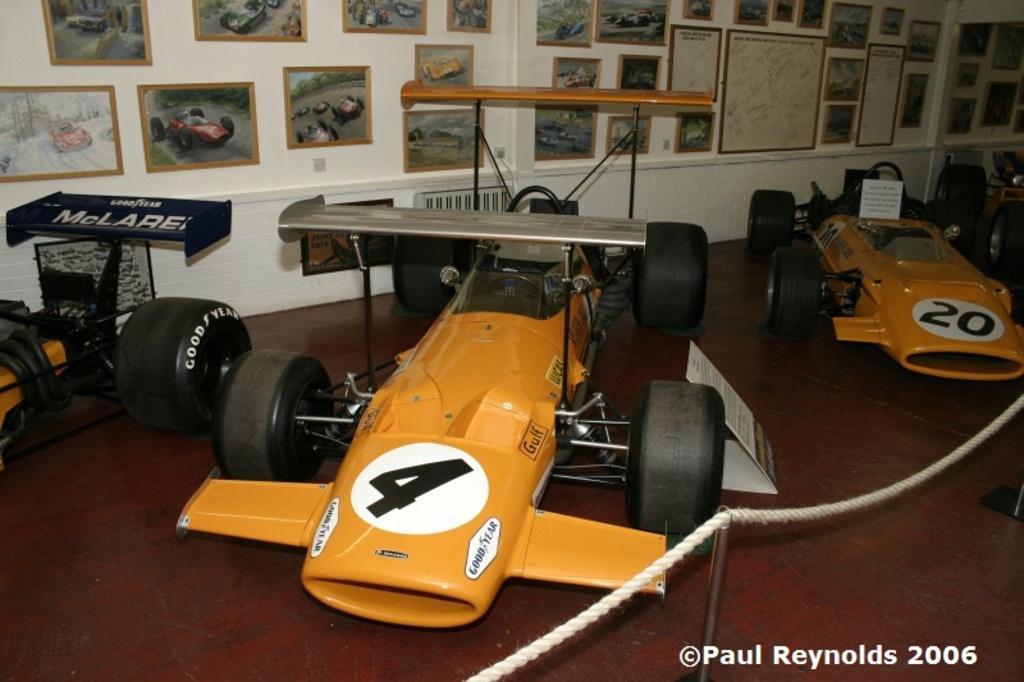Can you describe this image briefly? In this image there are three racing cars, in this image there is a rope,there are photo frames of cars,there is a white wall behind the cars. 